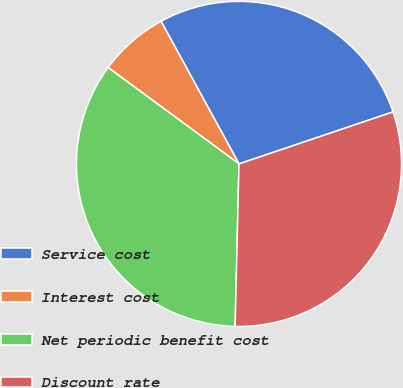<chart> <loc_0><loc_0><loc_500><loc_500><pie_chart><fcel>Service cost<fcel>Interest cost<fcel>Net periodic benefit cost<fcel>Discount rate<nl><fcel>27.78%<fcel>6.94%<fcel>34.72%<fcel>30.56%<nl></chart> 